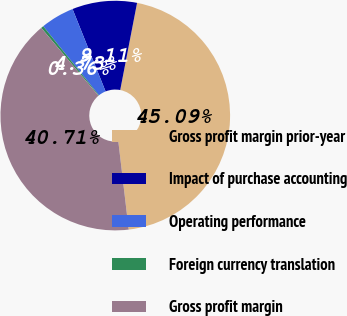Convert chart. <chart><loc_0><loc_0><loc_500><loc_500><pie_chart><fcel>Gross profit margin prior-year<fcel>Impact of purchase accounting<fcel>Operating performance<fcel>Foreign currency translation<fcel>Gross profit margin<nl><fcel>45.09%<fcel>9.11%<fcel>4.73%<fcel>0.36%<fcel>40.71%<nl></chart> 